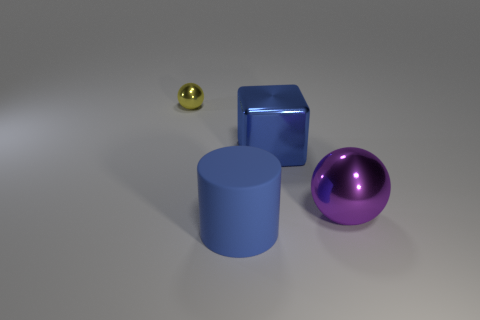Is there anything else that has the same material as the cylinder?
Give a very brief answer. No. Are there any other things that are the same size as the yellow shiny ball?
Provide a succinct answer. No. How many objects are either small things or big blue rubber cylinders?
Your answer should be very brief. 2. There is a large thing that is in front of the big purple metal object; are there any big objects that are behind it?
Provide a short and direct response. Yes. Is the number of metallic balls that are in front of the yellow metal ball greater than the number of yellow metallic things in front of the blue cylinder?
Your answer should be compact. Yes. What is the material of the block that is the same color as the big rubber object?
Offer a very short reply. Metal. What number of cylinders are the same color as the large block?
Provide a short and direct response. 1. There is a big shiny object that is to the left of the large sphere; does it have the same color as the large object in front of the large purple ball?
Make the answer very short. Yes. Are there any large objects behind the rubber cylinder?
Provide a short and direct response. Yes. What is the yellow sphere made of?
Your answer should be compact. Metal. 